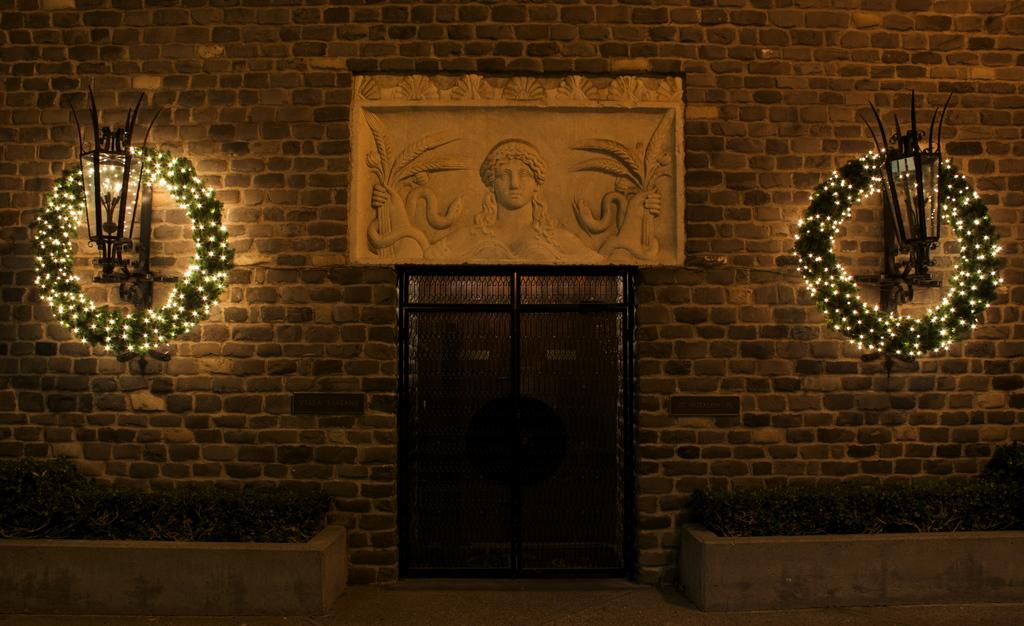What type of vegetation is visible in the image? There is grass in the image. What decorations can be seen on the sides of the image? There are wreaths decorated with lights on the left and right sides. What structure is located in the middle of the image? There is a door in the middle of the image. What artwork is present on the wall in the middle of the image? There is a sculpture on the wall in the middle of the image. What type of faucet is installed on the door in the image? There is no faucet present on the door in the image. What organization is responsible for the decorations in the image? The image does not provide information about any organization responsible for the decorations. 